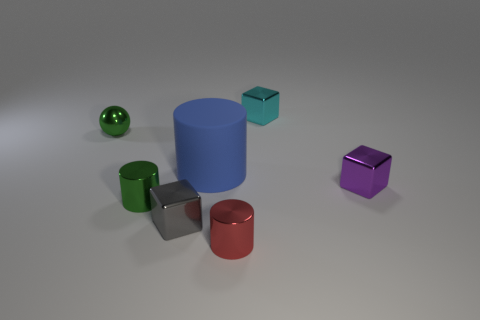Subtract all purple cylinders. Subtract all purple balls. How many cylinders are left? 3 Add 1 small spheres. How many objects exist? 8 Subtract all blocks. How many objects are left? 4 Subtract 0 brown spheres. How many objects are left? 7 Subtract all small red things. Subtract all gray cubes. How many objects are left? 5 Add 7 blue rubber things. How many blue rubber things are left? 8 Add 5 tiny green metallic objects. How many tiny green metallic objects exist? 7 